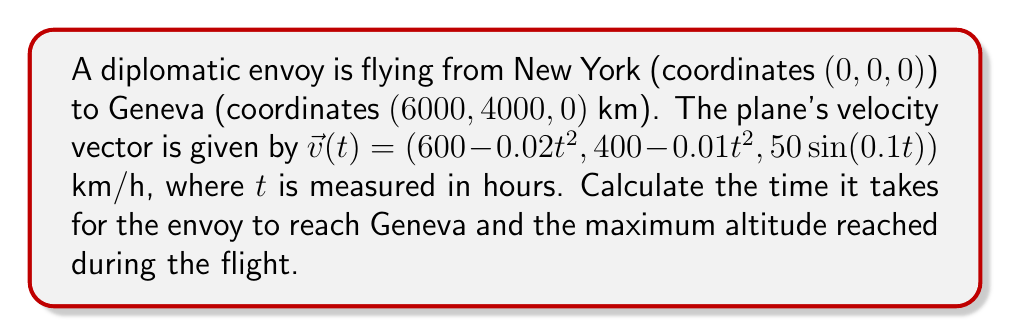Can you solve this math problem? 1. To find the time of arrival, we need to integrate the velocity vector:

   $\vec{r}(t) = \int \vec{v}(t) dt = (600t - \frac{0.02t^3}{3}, 400t - \frac{0.01t^3}{3}, -500\cos(0.1t)) + \vec{C}$

2. Given the initial position (0, 0, 0), we can determine $\vec{C} = (0, 0, 500)$. So:

   $\vec{r}(t) = (600t - \frac{0.02t^3}{3}, 400t - \frac{0.01t^3}{3}, 500(1-\cos(0.1t)))$

3. To find the time of arrival, we equate the x and y components to the Geneva coordinates:

   $600t - \frac{0.02t^3}{3} = 6000$
   $400t - \frac{0.01t^3}{3} = 4000$

4. Solving either equation (they're equivalent) gives $t \approx 10.54$ hours.

5. For the maximum altitude, we find the maximum of the z-component:

   $z(t) = 500(1-\cos(0.1t))$

   The maximum occurs when $\cos(0.1t) = -1$, or $t = 10\pi \approx 31.42$ hours.

6. The maximum altitude is:

   $z_{max} = 500(1-(-1)) = 1000$ km

However, this occurs after the arrival in Geneva. The actual maximum altitude during the flight is:

$z(10.54) = 500(1-\cos(1.054)) \approx 431.03$ km
Answer: Time to reach Geneva: 10.54 hours. Maximum altitude: 431.03 km. 